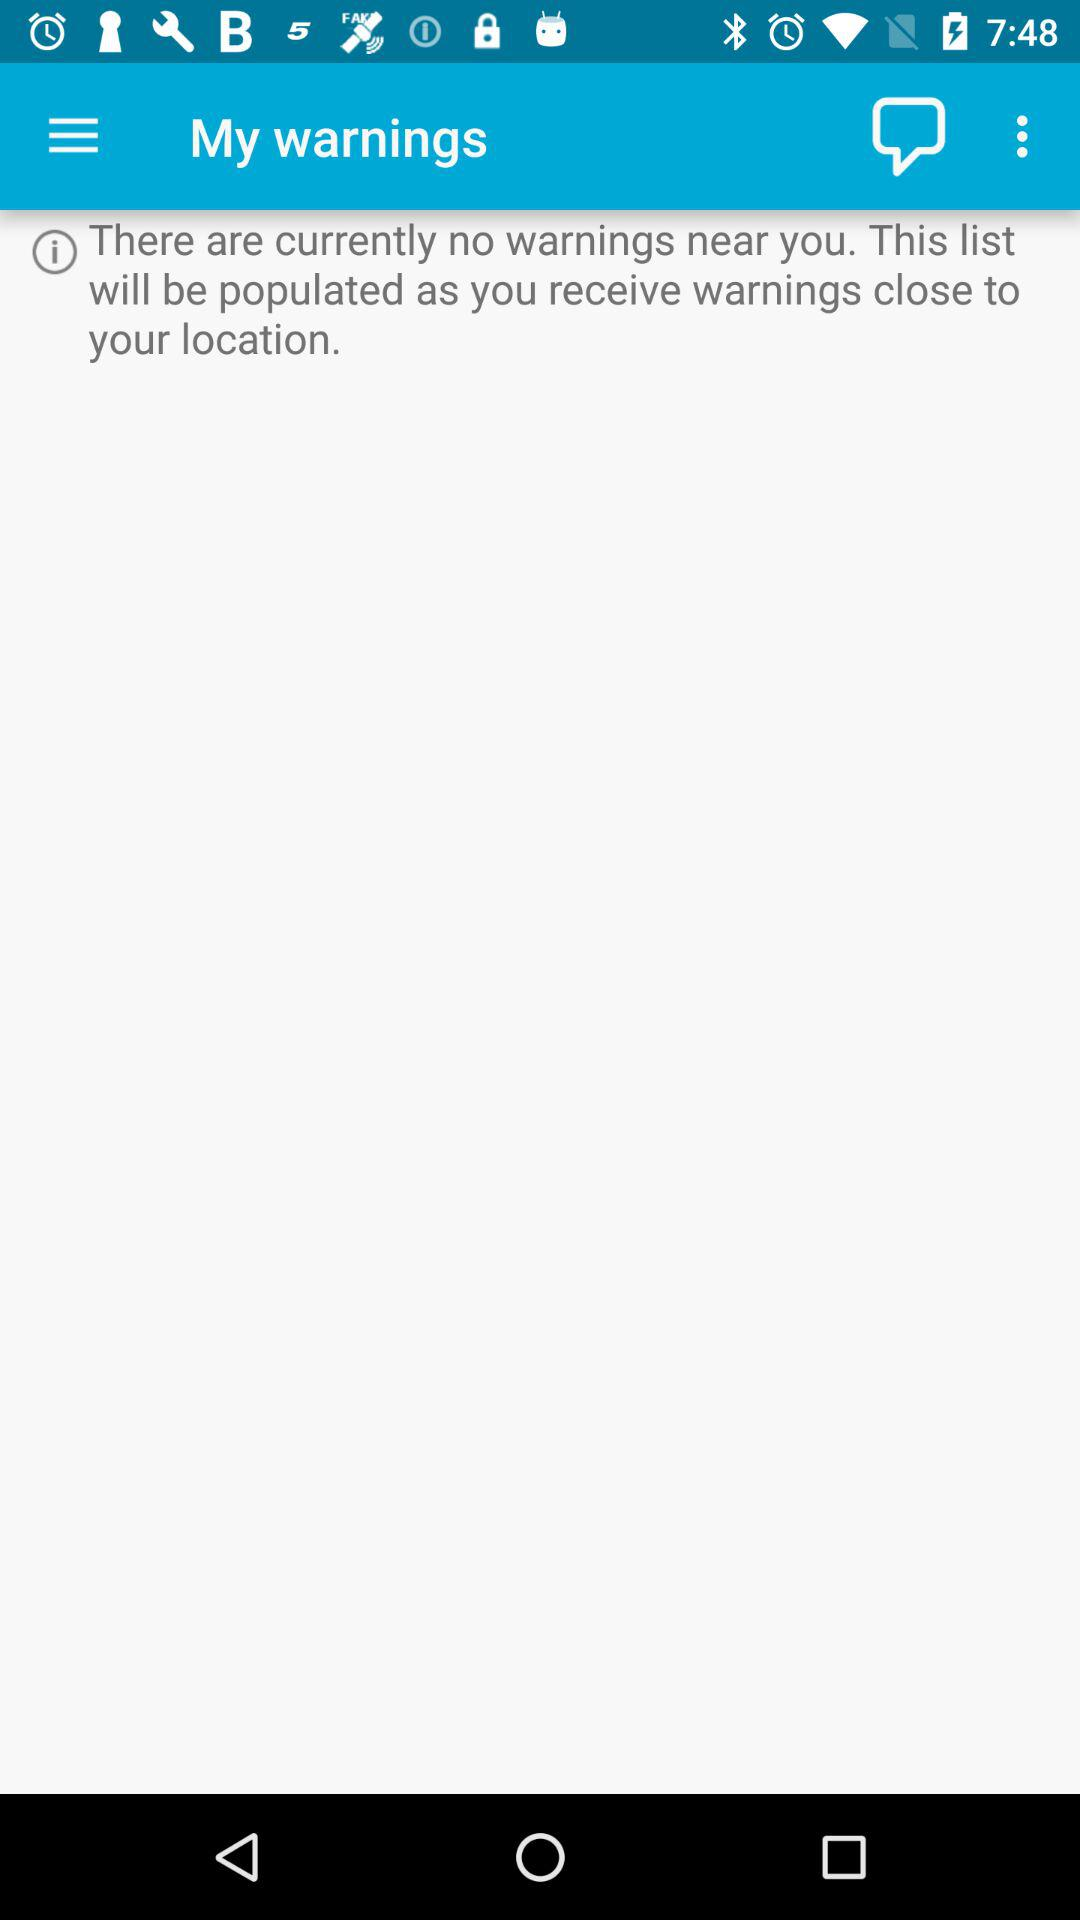How many warnings are there? There is no warning. 